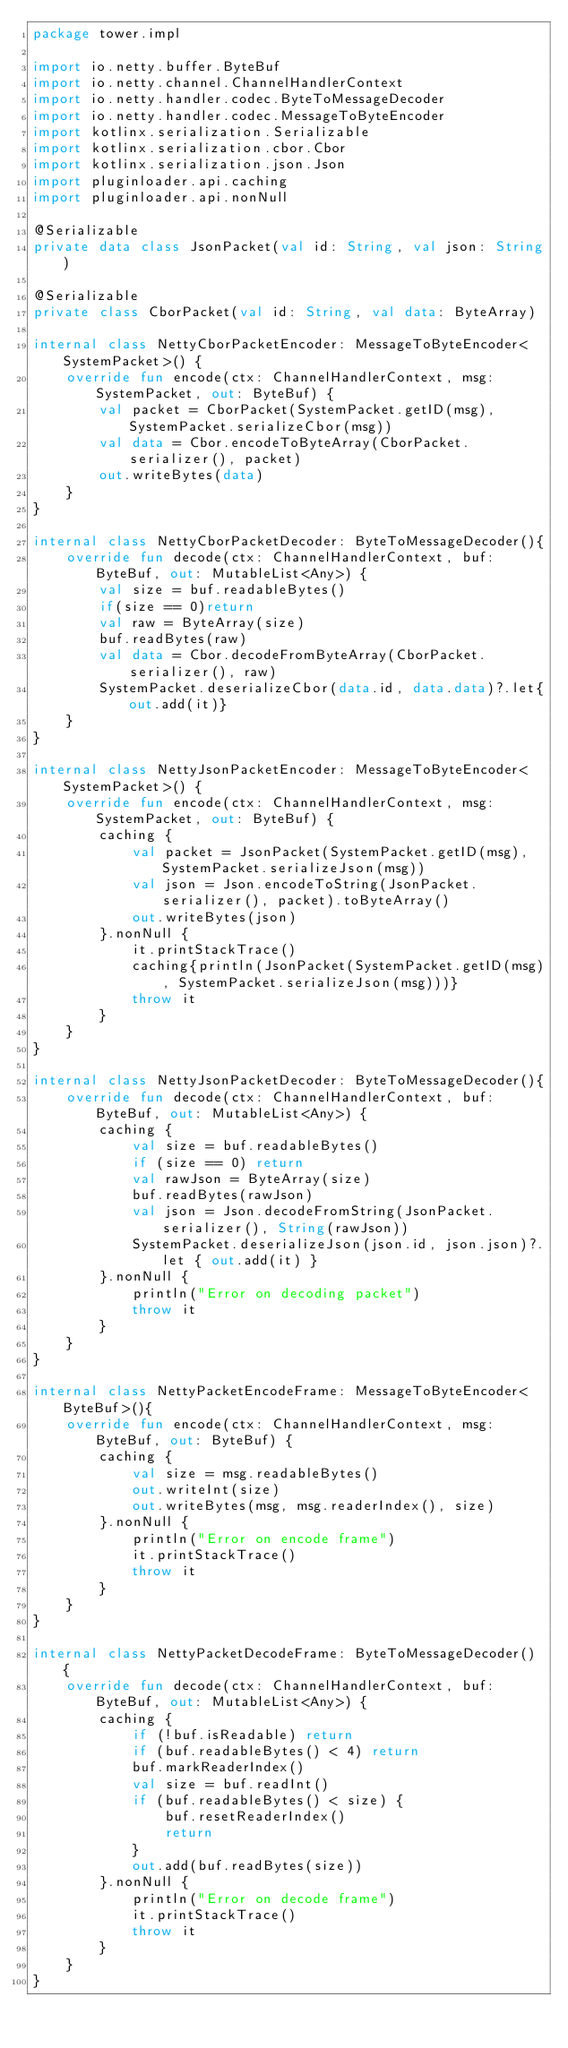<code> <loc_0><loc_0><loc_500><loc_500><_Kotlin_>package tower.impl

import io.netty.buffer.ByteBuf
import io.netty.channel.ChannelHandlerContext
import io.netty.handler.codec.ByteToMessageDecoder
import io.netty.handler.codec.MessageToByteEncoder
import kotlinx.serialization.Serializable
import kotlinx.serialization.cbor.Cbor
import kotlinx.serialization.json.Json
import pluginloader.api.caching
import pluginloader.api.nonNull

@Serializable
private data class JsonPacket(val id: String, val json: String)

@Serializable
private class CborPacket(val id: String, val data: ByteArray)

internal class NettyCborPacketEncoder: MessageToByteEncoder<SystemPacket>() {
    override fun encode(ctx: ChannelHandlerContext, msg: SystemPacket, out: ByteBuf) {
        val packet = CborPacket(SystemPacket.getID(msg), SystemPacket.serializeCbor(msg))
        val data = Cbor.encodeToByteArray(CborPacket.serializer(), packet)
        out.writeBytes(data)
    }
}

internal class NettyCborPacketDecoder: ByteToMessageDecoder(){
    override fun decode(ctx: ChannelHandlerContext, buf: ByteBuf, out: MutableList<Any>) {
        val size = buf.readableBytes()
        if(size == 0)return
        val raw = ByteArray(size)
        buf.readBytes(raw)
        val data = Cbor.decodeFromByteArray(CborPacket.serializer(), raw)
        SystemPacket.deserializeCbor(data.id, data.data)?.let{out.add(it)}
    }
}

internal class NettyJsonPacketEncoder: MessageToByteEncoder<SystemPacket>() {
    override fun encode(ctx: ChannelHandlerContext, msg: SystemPacket, out: ByteBuf) {
        caching {
            val packet = JsonPacket(SystemPacket.getID(msg), SystemPacket.serializeJson(msg))
            val json = Json.encodeToString(JsonPacket.serializer(), packet).toByteArray()
            out.writeBytes(json)
        }.nonNull {
            it.printStackTrace()
            caching{println(JsonPacket(SystemPacket.getID(msg), SystemPacket.serializeJson(msg)))}
            throw it
        }
    }
}

internal class NettyJsonPacketDecoder: ByteToMessageDecoder(){
    override fun decode(ctx: ChannelHandlerContext, buf: ByteBuf, out: MutableList<Any>) {
        caching {
            val size = buf.readableBytes()
            if (size == 0) return
            val rawJson = ByteArray(size)
            buf.readBytes(rawJson)
            val json = Json.decodeFromString(JsonPacket.serializer(), String(rawJson))
            SystemPacket.deserializeJson(json.id, json.json)?.let { out.add(it) }
        }.nonNull {
            println("Error on decoding packet")
            throw it
        }
    }
}

internal class NettyPacketEncodeFrame: MessageToByteEncoder<ByteBuf>(){
    override fun encode(ctx: ChannelHandlerContext, msg: ByteBuf, out: ByteBuf) {
        caching {
            val size = msg.readableBytes()
            out.writeInt(size)
            out.writeBytes(msg, msg.readerIndex(), size)
        }.nonNull {
            println("Error on encode frame")
            it.printStackTrace()
            throw it
        }
    }
}

internal class NettyPacketDecodeFrame: ByteToMessageDecoder() {
    override fun decode(ctx: ChannelHandlerContext, buf: ByteBuf, out: MutableList<Any>) {
        caching {
            if (!buf.isReadable) return
            if (buf.readableBytes() < 4) return
            buf.markReaderIndex()
            val size = buf.readInt()
            if (buf.readableBytes() < size) {
                buf.resetReaderIndex()
                return
            }
            out.add(buf.readBytes(size))
        }.nonNull {
            println("Error on decode frame")
            it.printStackTrace()
            throw it
        }
    }
}</code> 